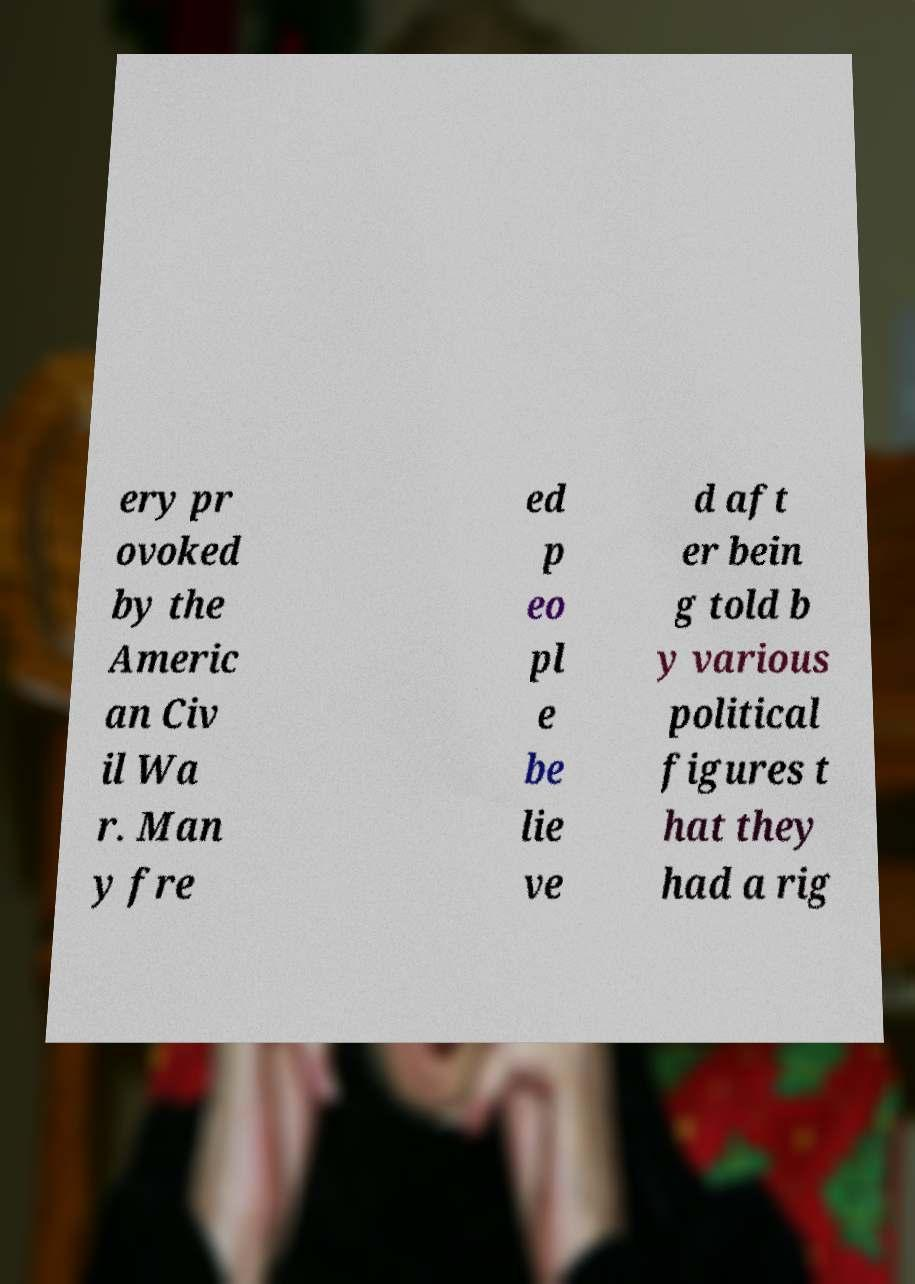Please read and relay the text visible in this image. What does it say? ery pr ovoked by the Americ an Civ il Wa r. Man y fre ed p eo pl e be lie ve d aft er bein g told b y various political figures t hat they had a rig 